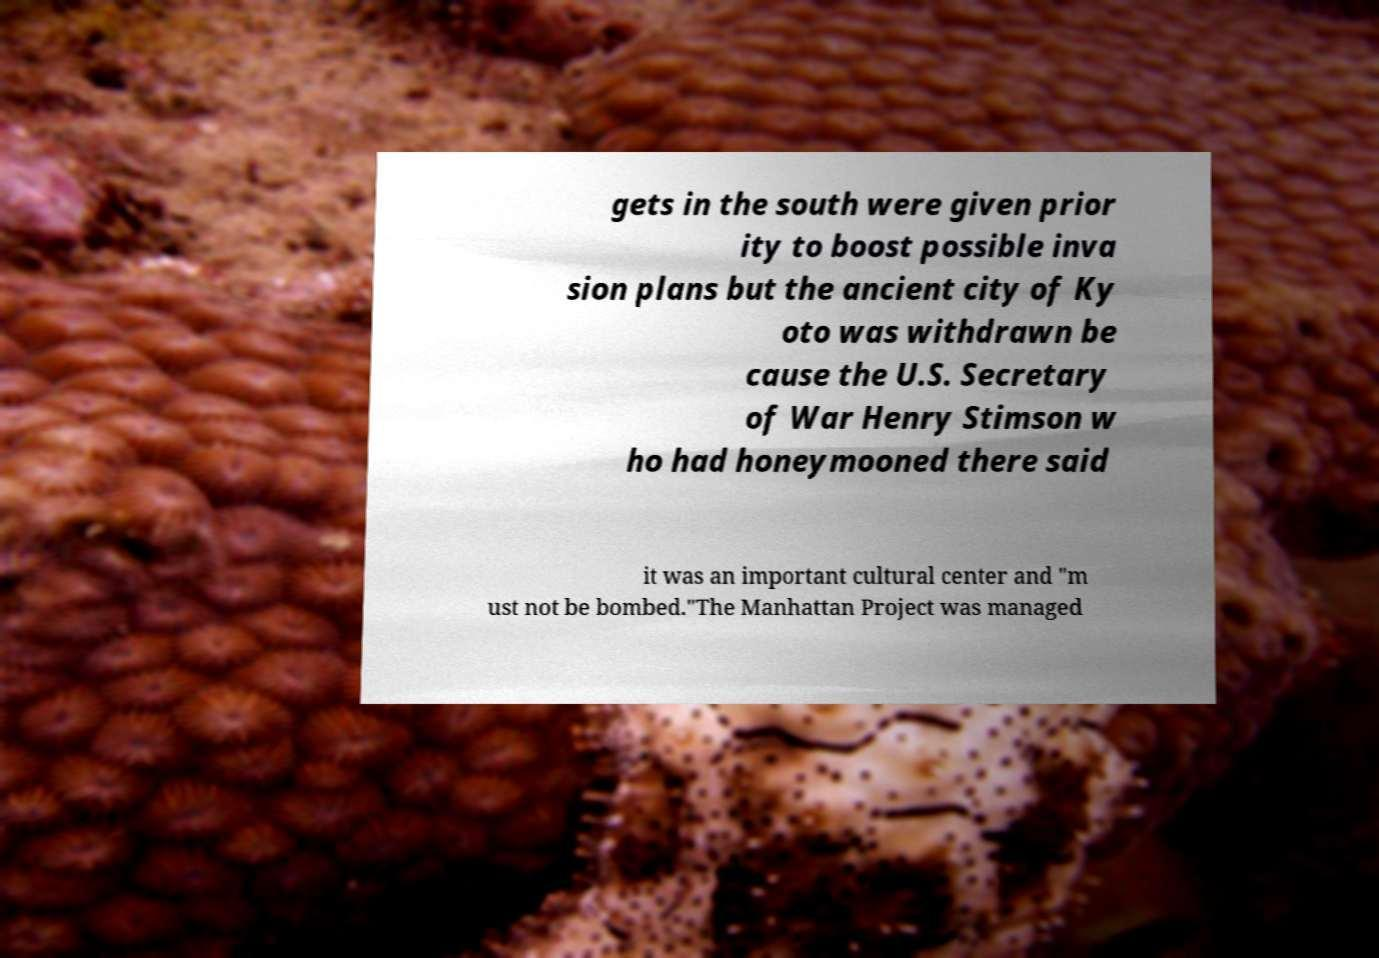Can you accurately transcribe the text from the provided image for me? gets in the south were given prior ity to boost possible inva sion plans but the ancient city of Ky oto was withdrawn be cause the U.S. Secretary of War Henry Stimson w ho had honeymooned there said it was an important cultural center and "m ust not be bombed."The Manhattan Project was managed 